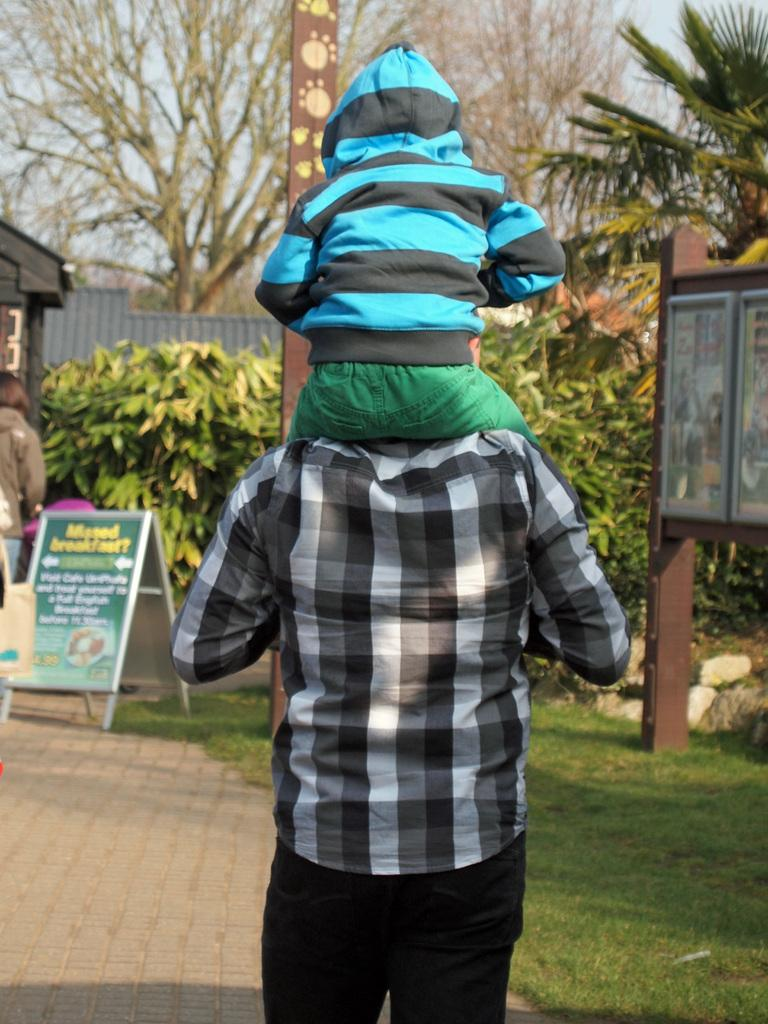What is the main subject in the foreground of the image? There is a kid in the foreground of the image. What is the kid doing in the image? The kid is sitting on a man. What can be seen in the background of the image? There are boards, at least one person, a building, trees, grass, and the ground visible in the background of the image. What type of cactus can be seen in the image? There is no cactus present in the image. How does the gate in the image open and close? There is no gate present in the image. 